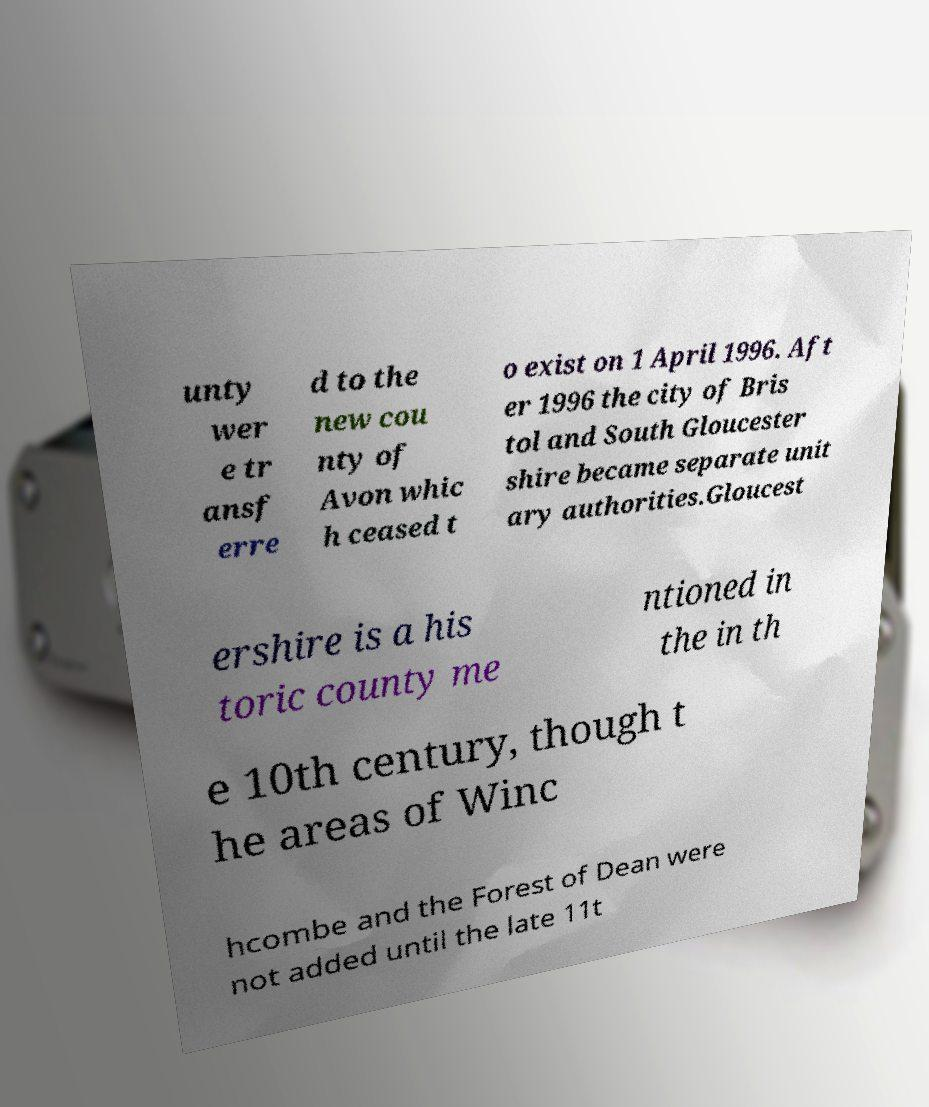Could you extract and type out the text from this image? unty wer e tr ansf erre d to the new cou nty of Avon whic h ceased t o exist on 1 April 1996. Aft er 1996 the city of Bris tol and South Gloucester shire became separate unit ary authorities.Gloucest ershire is a his toric county me ntioned in the in th e 10th century, though t he areas of Winc hcombe and the Forest of Dean were not added until the late 11t 